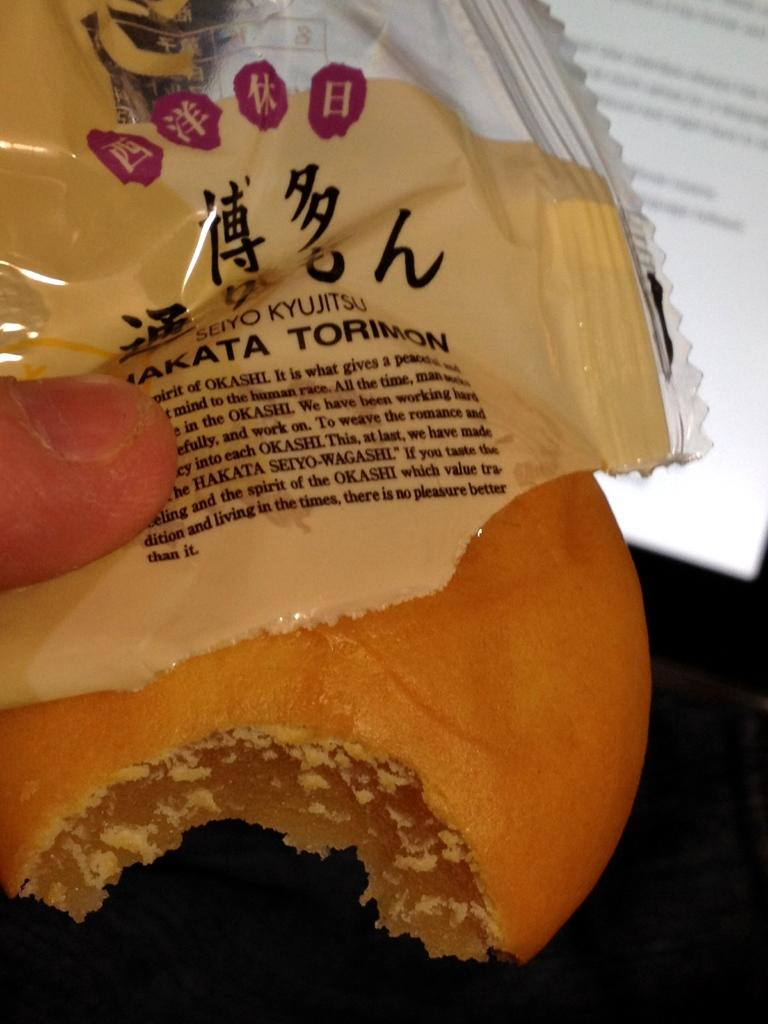What type of food item can be seen in the image? There is a food item in the image, but its specific type is not mentioned in the facts. What is covering the food item in the image? There is a cover in the image. Whose finger is visible in the image? A person's finger is visible in the image. What can be seen on the screen in the image? There is a screen with text in the image. Is the person wearing a veil in the image? There is no mention of a veil or any clothing in the image. Can the person be seen lifting the food item in the image? The facts do not mention the person lifting the food item, only that their finger is visible. 